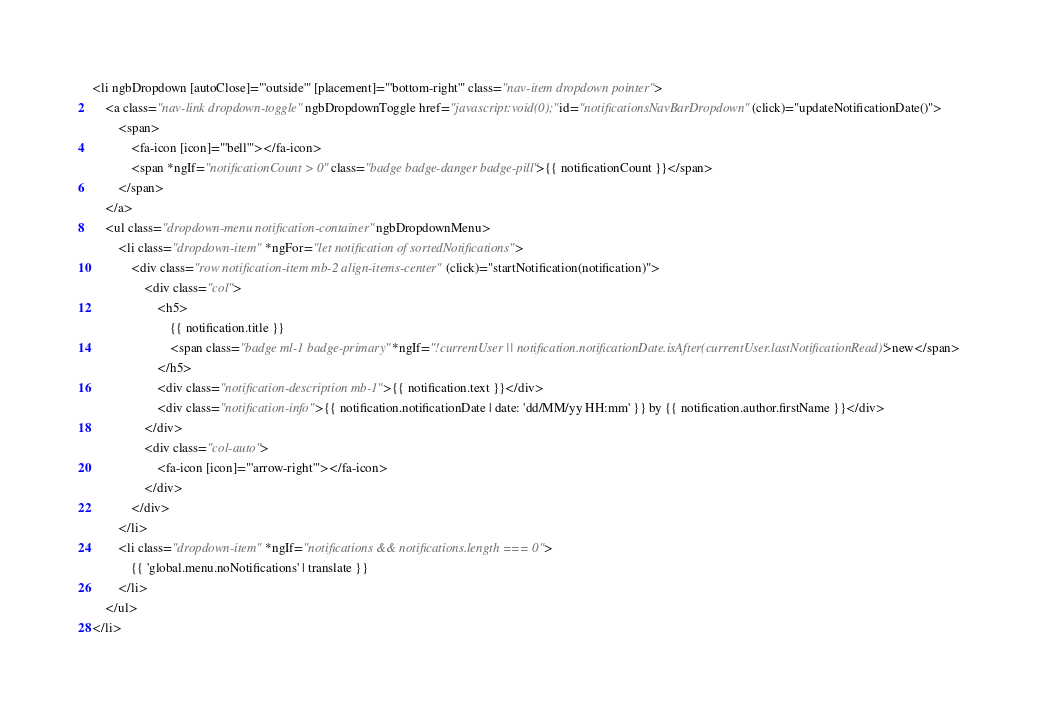<code> <loc_0><loc_0><loc_500><loc_500><_HTML_><li ngbDropdown [autoClose]="'outside'" [placement]="'bottom-right'" class="nav-item dropdown pointer">
    <a class="nav-link dropdown-toggle" ngbDropdownToggle href="javascript:void(0);" id="notificationsNavBarDropdown" (click)="updateNotificationDate()">
        <span>
            <fa-icon [icon]="'bell'"></fa-icon>
            <span *ngIf="notificationCount > 0" class="badge badge-danger badge-pill">{{ notificationCount }}</span>
        </span>
    </a>
    <ul class="dropdown-menu notification-container" ngbDropdownMenu>
        <li class="dropdown-item" *ngFor="let notification of sortedNotifications">
            <div class="row notification-item mb-2 align-items-center" (click)="startNotification(notification)">
                <div class="col">
                    <h5>
                        {{ notification.title }}
                        <span class="badge ml-1 badge-primary" *ngIf="!currentUser || notification.notificationDate.isAfter(currentUser.lastNotificationRead)">new</span>
                    </h5>
                    <div class="notification-description mb-1">{{ notification.text }}</div>
                    <div class="notification-info">{{ notification.notificationDate | date: 'dd/MM/yy HH:mm' }} by {{ notification.author.firstName }}</div>
                </div>
                <div class="col-auto">
                    <fa-icon [icon]="'arrow-right'"></fa-icon>
                </div>
            </div>
        </li>
        <li class="dropdown-item" *ngIf="notifications && notifications.length === 0">
            {{ 'global.menu.noNotifications' | translate }}
        </li>
    </ul>
</li>
</code> 